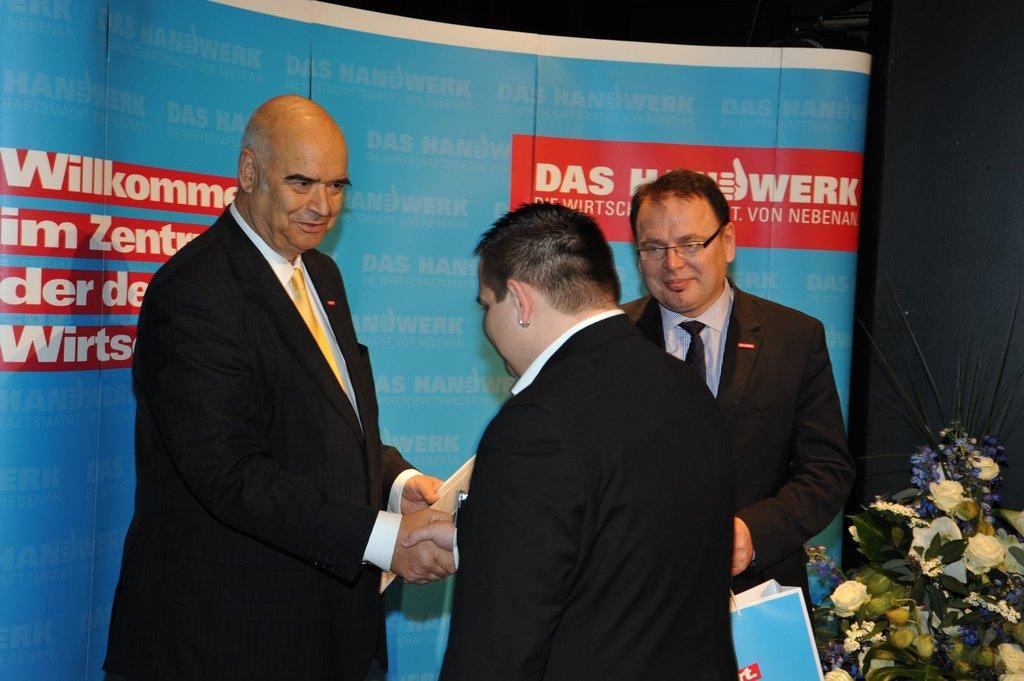Please provide a concise description of this image. In this image I can see three persons wearing white shirts and black blazers are standing. I can see a person is holding a blue colored bag and another person is holding an object in his hand. In the background I can see a blue colored banner, the black colored surface and a huge flower bouquet which is cream, purple and green in color. 